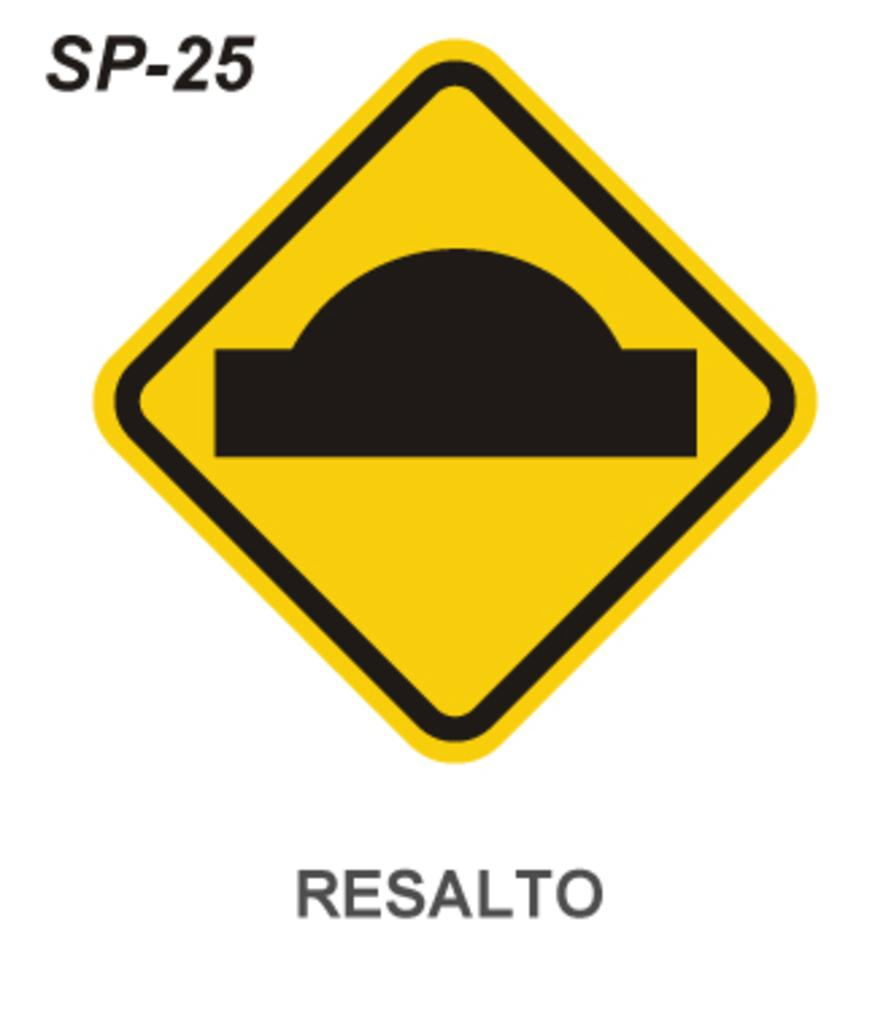<image>
Give a short and clear explanation of the subsequent image. A yellow road sign image with RESALTO below it 